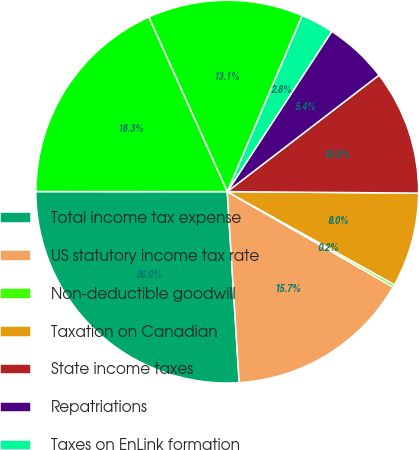Convert chart. <chart><loc_0><loc_0><loc_500><loc_500><pie_chart><fcel>Total income tax expense<fcel>US statutory income tax rate<fcel>Non-deductible goodwill<fcel>Taxation on Canadian<fcel>State income taxes<fcel>Repatriations<fcel>Taxes on EnLink formation<fcel>Other<fcel>Effective income tax rate<nl><fcel>26.0%<fcel>15.7%<fcel>0.22%<fcel>7.96%<fcel>10.54%<fcel>5.38%<fcel>2.8%<fcel>13.12%<fcel>18.27%<nl></chart> 